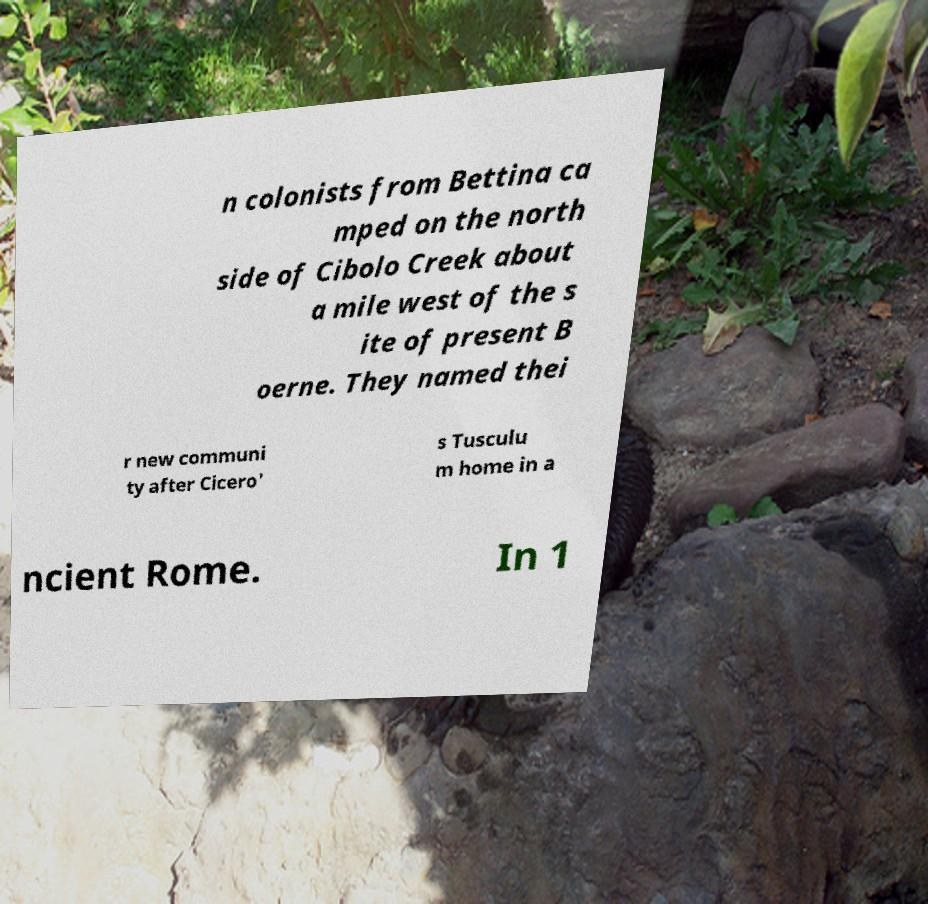Could you extract and type out the text from this image? n colonists from Bettina ca mped on the north side of Cibolo Creek about a mile west of the s ite of present B oerne. They named thei r new communi ty after Cicero' s Tusculu m home in a ncient Rome. In 1 